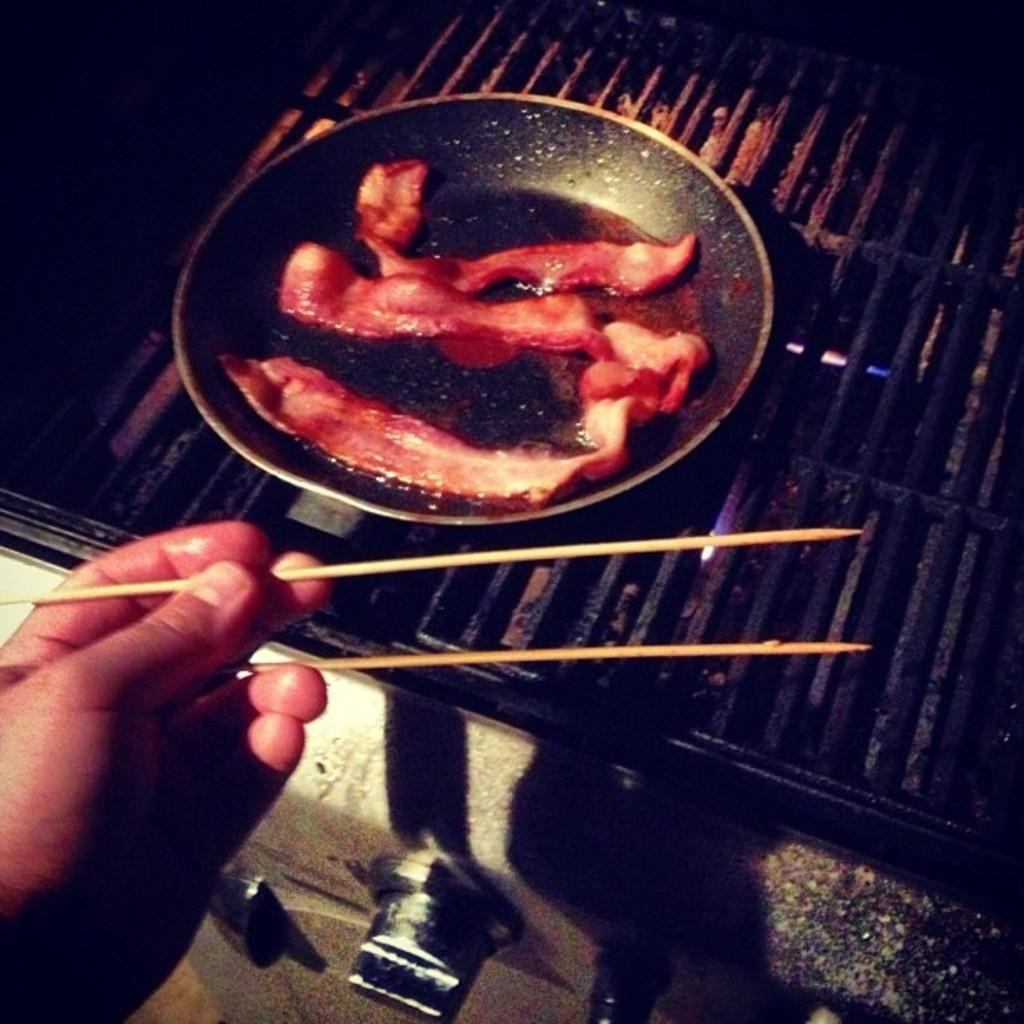What is being cooked on the grill in the image? There is a pan with meat on the grill in the image. What else can be seen in the image besides the grill? There are buttons visible in the image. What is the person in the image using to eat? A person's hand holding chopsticks is present in the image. What type of animal can be seen on the moon in the image? There is no moon or animal present in the image. 